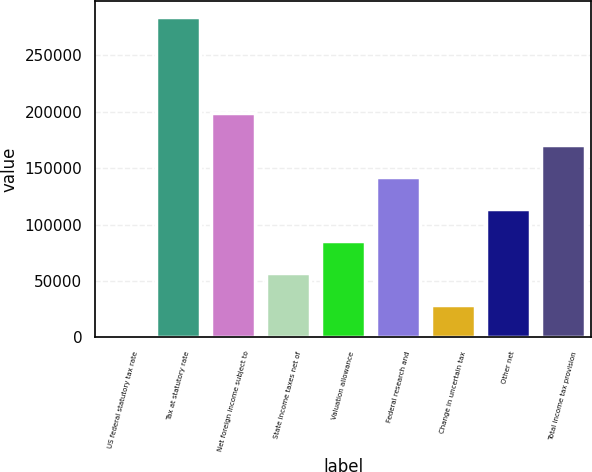Convert chart. <chart><loc_0><loc_0><loc_500><loc_500><bar_chart><fcel>US federal statutory tax rate<fcel>Tax at statutory rate<fcel>Net foreign income subject to<fcel>State income taxes net of<fcel>Valuation allowance<fcel>Federal research and<fcel>Change in uncertain tax<fcel>Other net<fcel>Total income tax provision<nl><fcel>35<fcel>283540<fcel>198488<fcel>56736<fcel>85086.5<fcel>141788<fcel>28385.5<fcel>113437<fcel>170138<nl></chart> 